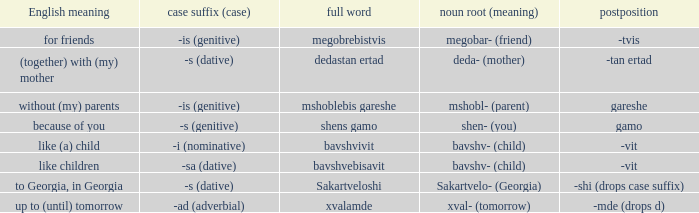What is English Meaning, when Full Word is "Shens Gamo"? Because of you. 